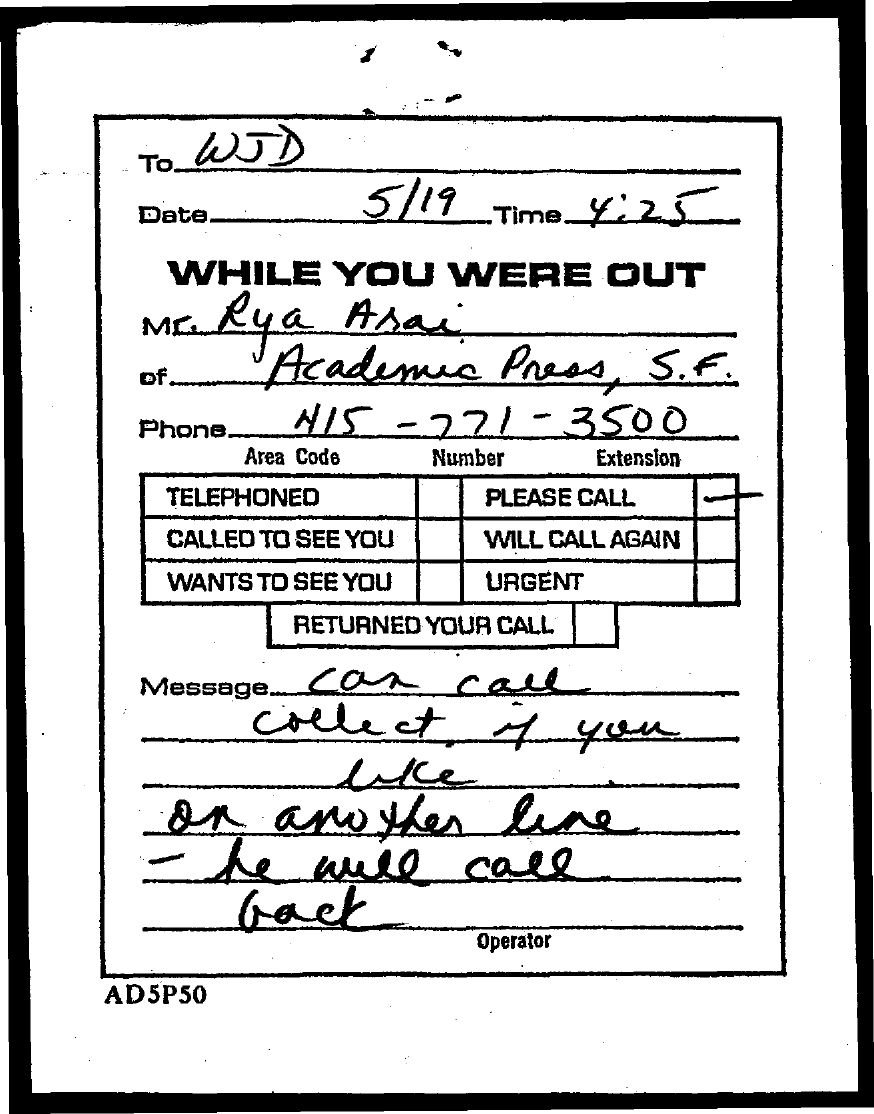To whom, the message is addressed?
Give a very brief answer. WJD. What is the date mentioned in this document?
Make the answer very short. 5/19. What is the time mentioned in the document?
Offer a very short reply. 4:25. What is the telephone no of Mr. Rya Arai?
Keep it short and to the point. 415 - 771 - 3500. 